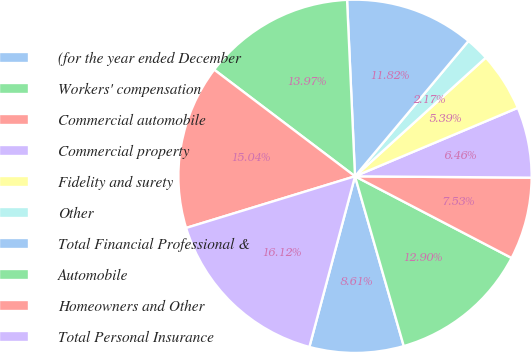Convert chart. <chart><loc_0><loc_0><loc_500><loc_500><pie_chart><fcel>(for the year ended December<fcel>Workers' compensation<fcel>Commercial automobile<fcel>Commercial property<fcel>Fidelity and surety<fcel>Other<fcel>Total Financial Professional &<fcel>Automobile<fcel>Homeowners and Other<fcel>Total Personal Insurance<nl><fcel>8.61%<fcel>12.9%<fcel>7.53%<fcel>6.46%<fcel>5.39%<fcel>2.17%<fcel>11.82%<fcel>13.97%<fcel>15.04%<fcel>16.12%<nl></chart> 